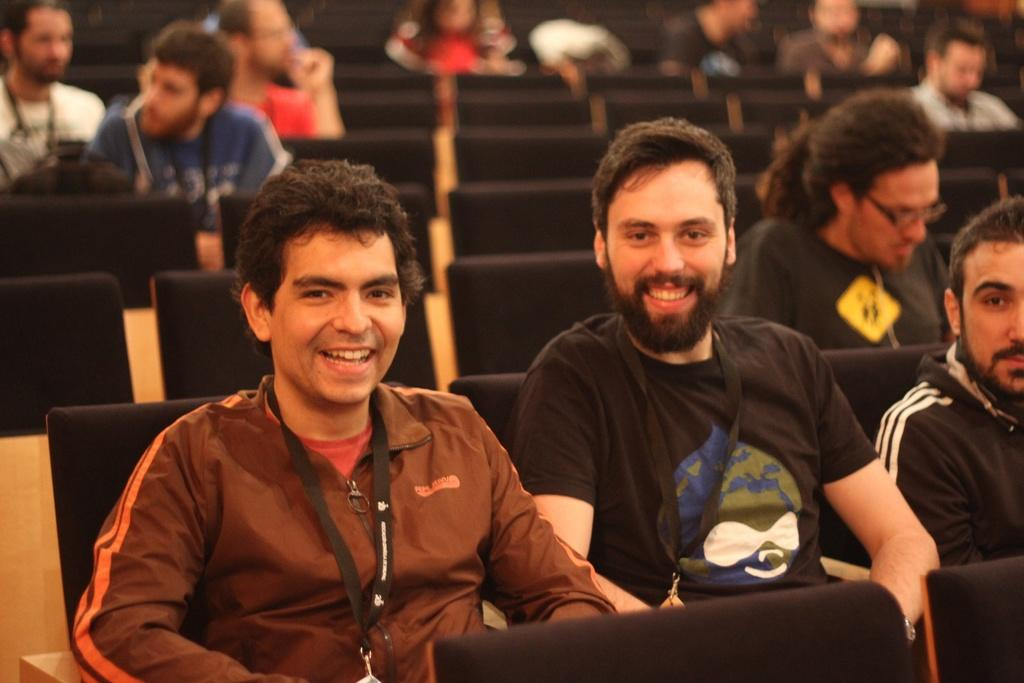What are the people in the image doing? The people in the image are sitting on chairs and smiling. What color are the chairs in the image? The chairs in the image are black. What can be seen attached to the chairs in the image? There are wire tags attached to the chairs in the image. How would you describe the background of the image? The background of the image is blurred. Can you tell me how many degrees the horse has in the image? There is no horse present in the image, so it is not possible to determine the number of degrees it might have. 